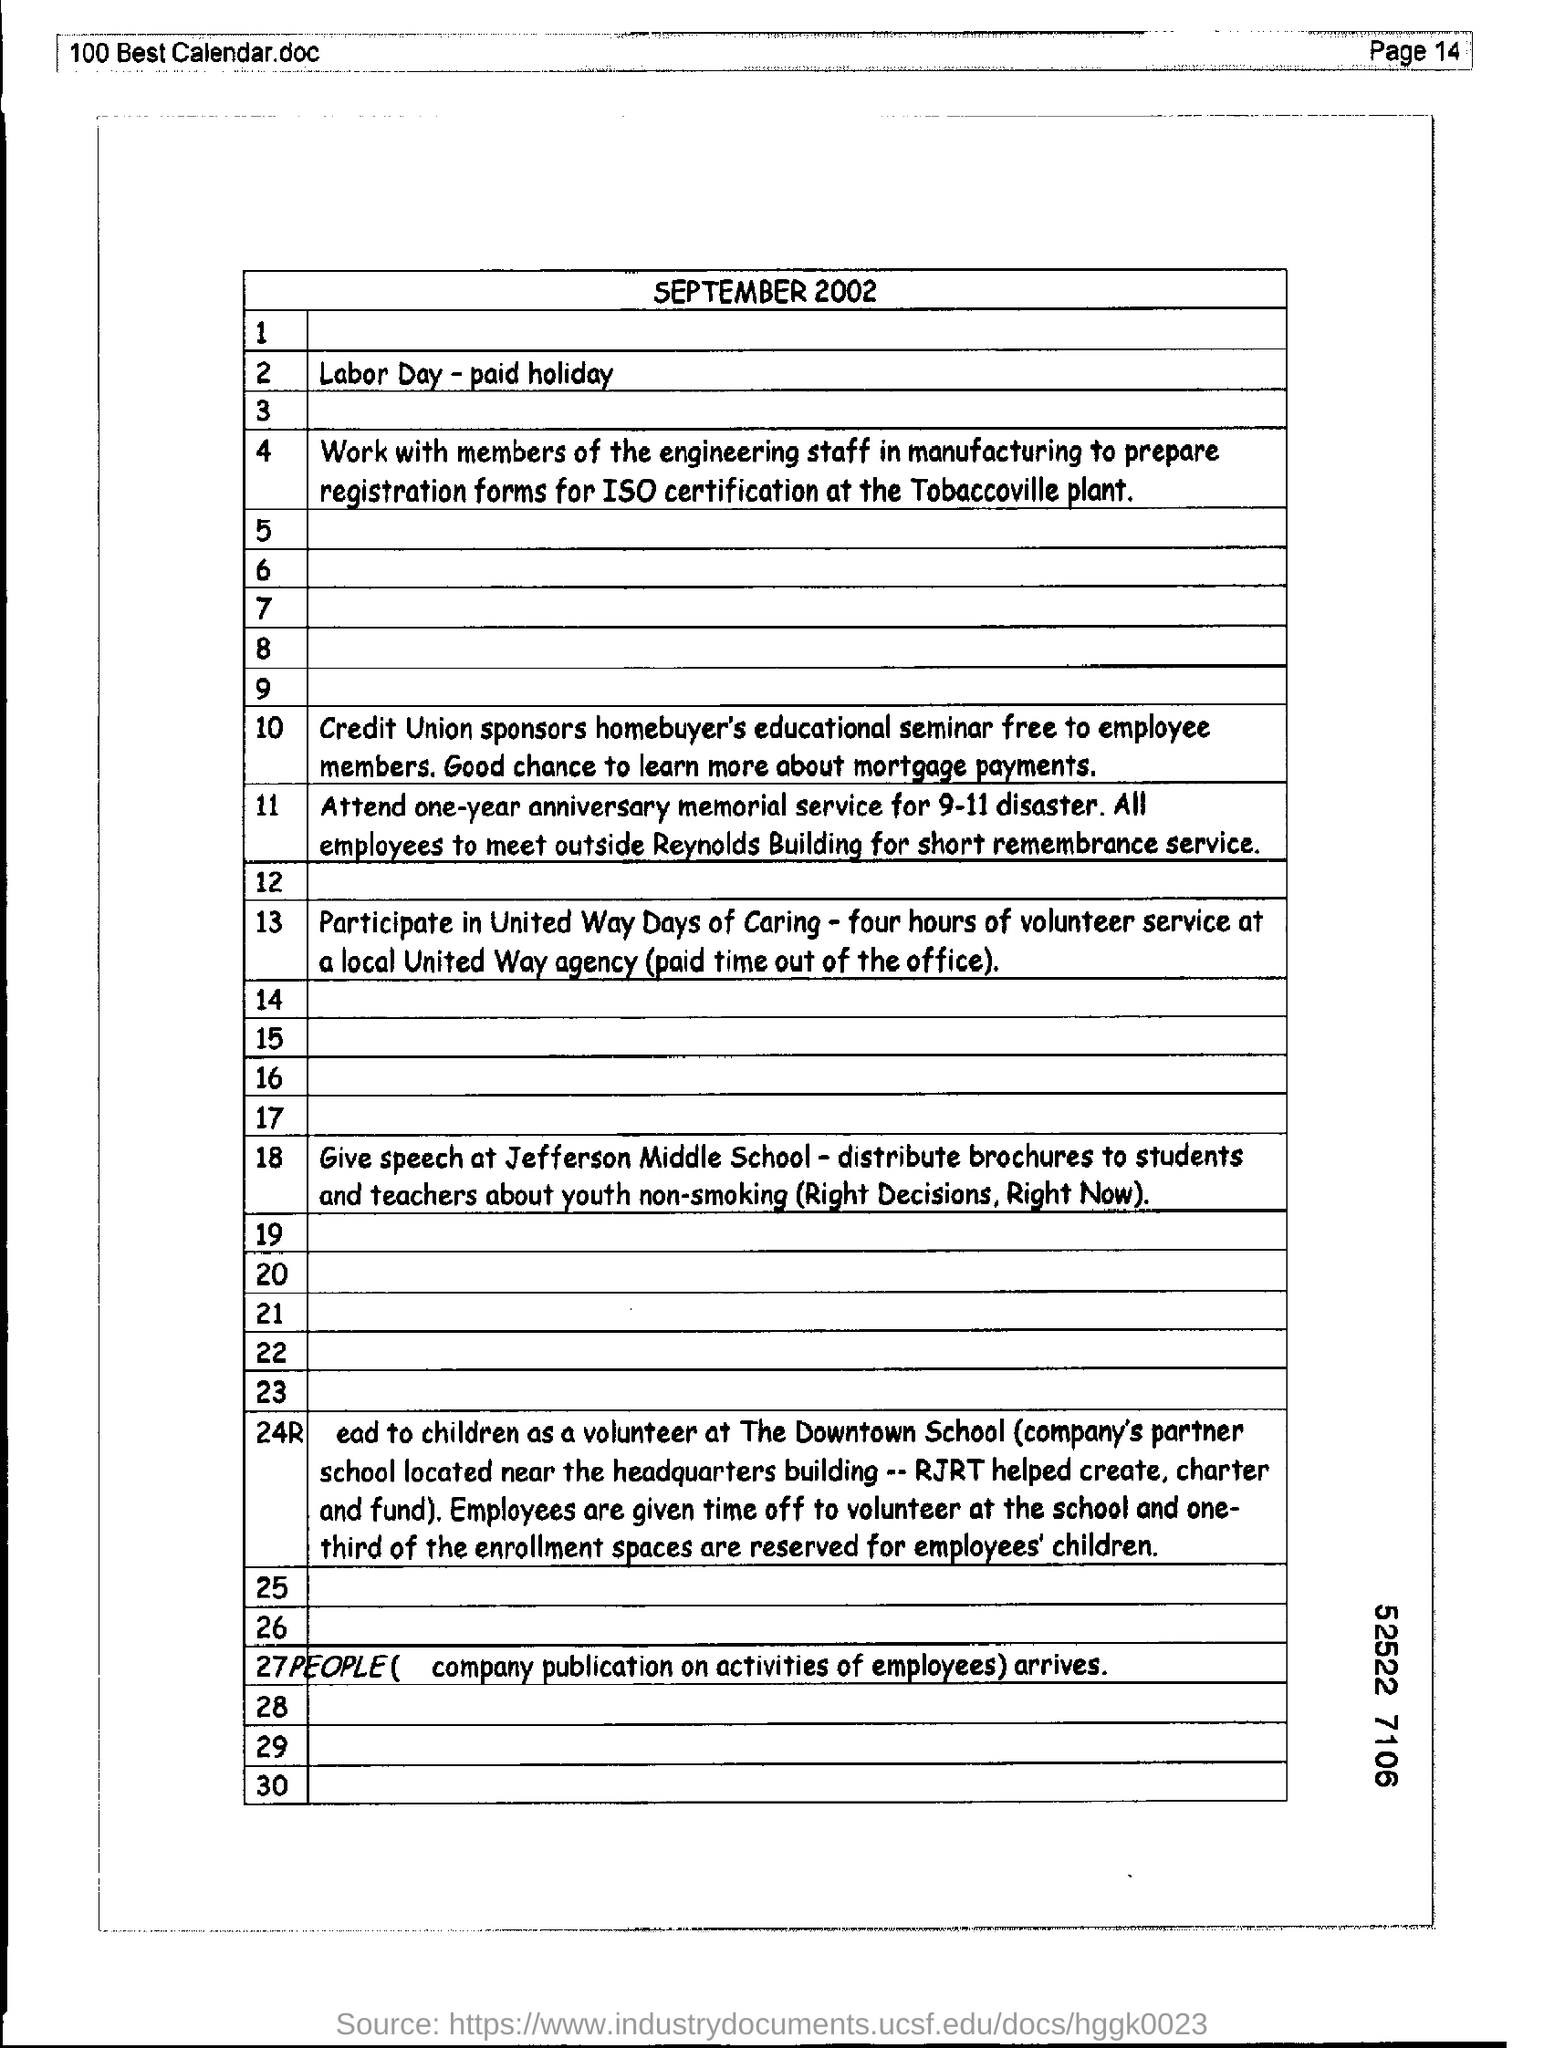Mention the page number at top right corner of the page ?
Provide a succinct answer. 14. 